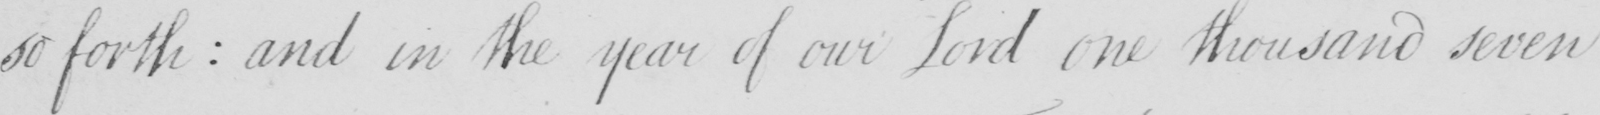Can you read and transcribe this handwriting? so forth  :  and in the year of our Lord one thousand seven 